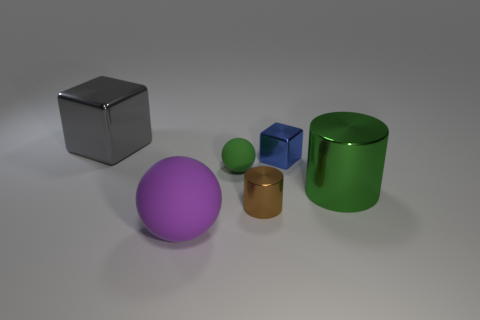Add 2 matte cylinders. How many objects exist? 8 Subtract all cubes. How many objects are left? 4 Add 1 yellow rubber blocks. How many yellow rubber blocks exist? 1 Subtract 0 brown cubes. How many objects are left? 6 Subtract all small blue things. Subtract all small cubes. How many objects are left? 4 Add 1 green rubber balls. How many green rubber balls are left? 2 